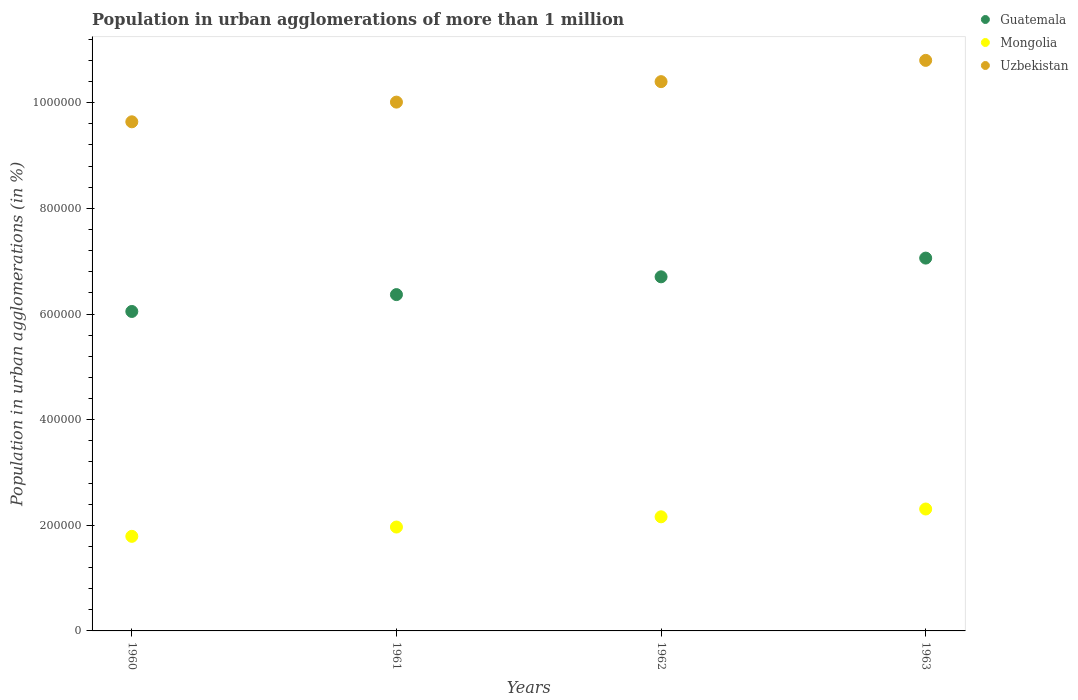How many different coloured dotlines are there?
Provide a short and direct response. 3. What is the population in urban agglomerations in Mongolia in 1960?
Offer a very short reply. 1.79e+05. Across all years, what is the maximum population in urban agglomerations in Mongolia?
Provide a succinct answer. 2.31e+05. Across all years, what is the minimum population in urban agglomerations in Mongolia?
Your response must be concise. 1.79e+05. What is the total population in urban agglomerations in Uzbekistan in the graph?
Give a very brief answer. 4.09e+06. What is the difference between the population in urban agglomerations in Mongolia in 1962 and that in 1963?
Ensure brevity in your answer.  -1.48e+04. What is the difference between the population in urban agglomerations in Mongolia in 1960 and the population in urban agglomerations in Uzbekistan in 1963?
Keep it short and to the point. -9.01e+05. What is the average population in urban agglomerations in Mongolia per year?
Ensure brevity in your answer.  2.06e+05. In the year 1962, what is the difference between the population in urban agglomerations in Guatemala and population in urban agglomerations in Uzbekistan?
Offer a very short reply. -3.70e+05. What is the ratio of the population in urban agglomerations in Guatemala in 1961 to that in 1963?
Keep it short and to the point. 0.9. Is the population in urban agglomerations in Guatemala in 1960 less than that in 1963?
Keep it short and to the point. Yes. What is the difference between the highest and the second highest population in urban agglomerations in Mongolia?
Make the answer very short. 1.48e+04. What is the difference between the highest and the lowest population in urban agglomerations in Mongolia?
Offer a terse response. 5.18e+04. Is the population in urban agglomerations in Guatemala strictly greater than the population in urban agglomerations in Uzbekistan over the years?
Offer a very short reply. No. How many dotlines are there?
Provide a succinct answer. 3. Are the values on the major ticks of Y-axis written in scientific E-notation?
Make the answer very short. No. Where does the legend appear in the graph?
Provide a succinct answer. Top right. How many legend labels are there?
Offer a terse response. 3. How are the legend labels stacked?
Offer a terse response. Vertical. What is the title of the graph?
Make the answer very short. Population in urban agglomerations of more than 1 million. What is the label or title of the X-axis?
Keep it short and to the point. Years. What is the label or title of the Y-axis?
Provide a succinct answer. Population in urban agglomerations (in %). What is the Population in urban agglomerations (in %) in Guatemala in 1960?
Your answer should be very brief. 6.05e+05. What is the Population in urban agglomerations (in %) of Mongolia in 1960?
Provide a succinct answer. 1.79e+05. What is the Population in urban agglomerations (in %) in Uzbekistan in 1960?
Your answer should be very brief. 9.64e+05. What is the Population in urban agglomerations (in %) in Guatemala in 1961?
Your response must be concise. 6.37e+05. What is the Population in urban agglomerations (in %) of Mongolia in 1961?
Provide a short and direct response. 1.97e+05. What is the Population in urban agglomerations (in %) of Uzbekistan in 1961?
Offer a very short reply. 1.00e+06. What is the Population in urban agglomerations (in %) in Guatemala in 1962?
Ensure brevity in your answer.  6.70e+05. What is the Population in urban agglomerations (in %) of Mongolia in 1962?
Keep it short and to the point. 2.16e+05. What is the Population in urban agglomerations (in %) in Uzbekistan in 1962?
Keep it short and to the point. 1.04e+06. What is the Population in urban agglomerations (in %) in Guatemala in 1963?
Make the answer very short. 7.06e+05. What is the Population in urban agglomerations (in %) of Mongolia in 1963?
Your answer should be compact. 2.31e+05. What is the Population in urban agglomerations (in %) in Uzbekistan in 1963?
Offer a terse response. 1.08e+06. Across all years, what is the maximum Population in urban agglomerations (in %) of Guatemala?
Offer a terse response. 7.06e+05. Across all years, what is the maximum Population in urban agglomerations (in %) of Mongolia?
Make the answer very short. 2.31e+05. Across all years, what is the maximum Population in urban agglomerations (in %) in Uzbekistan?
Offer a terse response. 1.08e+06. Across all years, what is the minimum Population in urban agglomerations (in %) in Guatemala?
Offer a very short reply. 6.05e+05. Across all years, what is the minimum Population in urban agglomerations (in %) in Mongolia?
Ensure brevity in your answer.  1.79e+05. Across all years, what is the minimum Population in urban agglomerations (in %) of Uzbekistan?
Your response must be concise. 9.64e+05. What is the total Population in urban agglomerations (in %) of Guatemala in the graph?
Make the answer very short. 2.62e+06. What is the total Population in urban agglomerations (in %) of Mongolia in the graph?
Provide a succinct answer. 8.23e+05. What is the total Population in urban agglomerations (in %) in Uzbekistan in the graph?
Make the answer very short. 4.09e+06. What is the difference between the Population in urban agglomerations (in %) in Guatemala in 1960 and that in 1961?
Keep it short and to the point. -3.19e+04. What is the difference between the Population in urban agglomerations (in %) in Mongolia in 1960 and that in 1961?
Provide a succinct answer. -1.76e+04. What is the difference between the Population in urban agglomerations (in %) of Uzbekistan in 1960 and that in 1961?
Your response must be concise. -3.73e+04. What is the difference between the Population in urban agglomerations (in %) in Guatemala in 1960 and that in 1962?
Provide a succinct answer. -6.56e+04. What is the difference between the Population in urban agglomerations (in %) of Mongolia in 1960 and that in 1962?
Your answer should be compact. -3.70e+04. What is the difference between the Population in urban agglomerations (in %) in Uzbekistan in 1960 and that in 1962?
Ensure brevity in your answer.  -7.60e+04. What is the difference between the Population in urban agglomerations (in %) of Guatemala in 1960 and that in 1963?
Offer a terse response. -1.01e+05. What is the difference between the Population in urban agglomerations (in %) of Mongolia in 1960 and that in 1963?
Your answer should be compact. -5.18e+04. What is the difference between the Population in urban agglomerations (in %) in Uzbekistan in 1960 and that in 1963?
Provide a short and direct response. -1.16e+05. What is the difference between the Population in urban agglomerations (in %) of Guatemala in 1961 and that in 1962?
Offer a terse response. -3.37e+04. What is the difference between the Population in urban agglomerations (in %) of Mongolia in 1961 and that in 1962?
Make the answer very short. -1.94e+04. What is the difference between the Population in urban agglomerations (in %) in Uzbekistan in 1961 and that in 1962?
Your answer should be very brief. -3.88e+04. What is the difference between the Population in urban agglomerations (in %) of Guatemala in 1961 and that in 1963?
Keep it short and to the point. -6.91e+04. What is the difference between the Population in urban agglomerations (in %) in Mongolia in 1961 and that in 1963?
Make the answer very short. -3.41e+04. What is the difference between the Population in urban agglomerations (in %) of Uzbekistan in 1961 and that in 1963?
Offer a terse response. -7.90e+04. What is the difference between the Population in urban agglomerations (in %) of Guatemala in 1962 and that in 1963?
Give a very brief answer. -3.54e+04. What is the difference between the Population in urban agglomerations (in %) in Mongolia in 1962 and that in 1963?
Your answer should be compact. -1.48e+04. What is the difference between the Population in urban agglomerations (in %) of Uzbekistan in 1962 and that in 1963?
Offer a very short reply. -4.03e+04. What is the difference between the Population in urban agglomerations (in %) of Guatemala in 1960 and the Population in urban agglomerations (in %) of Mongolia in 1961?
Your response must be concise. 4.08e+05. What is the difference between the Population in urban agglomerations (in %) in Guatemala in 1960 and the Population in urban agglomerations (in %) in Uzbekistan in 1961?
Provide a short and direct response. -3.96e+05. What is the difference between the Population in urban agglomerations (in %) of Mongolia in 1960 and the Population in urban agglomerations (in %) of Uzbekistan in 1961?
Provide a succinct answer. -8.22e+05. What is the difference between the Population in urban agglomerations (in %) in Guatemala in 1960 and the Population in urban agglomerations (in %) in Mongolia in 1962?
Make the answer very short. 3.89e+05. What is the difference between the Population in urban agglomerations (in %) in Guatemala in 1960 and the Population in urban agglomerations (in %) in Uzbekistan in 1962?
Provide a succinct answer. -4.35e+05. What is the difference between the Population in urban agglomerations (in %) in Mongolia in 1960 and the Population in urban agglomerations (in %) in Uzbekistan in 1962?
Ensure brevity in your answer.  -8.61e+05. What is the difference between the Population in urban agglomerations (in %) in Guatemala in 1960 and the Population in urban agglomerations (in %) in Mongolia in 1963?
Ensure brevity in your answer.  3.74e+05. What is the difference between the Population in urban agglomerations (in %) of Guatemala in 1960 and the Population in urban agglomerations (in %) of Uzbekistan in 1963?
Give a very brief answer. -4.75e+05. What is the difference between the Population in urban agglomerations (in %) of Mongolia in 1960 and the Population in urban agglomerations (in %) of Uzbekistan in 1963?
Your answer should be very brief. -9.01e+05. What is the difference between the Population in urban agglomerations (in %) of Guatemala in 1961 and the Population in urban agglomerations (in %) of Mongolia in 1962?
Your answer should be very brief. 4.21e+05. What is the difference between the Population in urban agglomerations (in %) in Guatemala in 1961 and the Population in urban agglomerations (in %) in Uzbekistan in 1962?
Offer a very short reply. -4.03e+05. What is the difference between the Population in urban agglomerations (in %) in Mongolia in 1961 and the Population in urban agglomerations (in %) in Uzbekistan in 1962?
Ensure brevity in your answer.  -8.43e+05. What is the difference between the Population in urban agglomerations (in %) of Guatemala in 1961 and the Population in urban agglomerations (in %) of Mongolia in 1963?
Ensure brevity in your answer.  4.06e+05. What is the difference between the Population in urban agglomerations (in %) in Guatemala in 1961 and the Population in urban agglomerations (in %) in Uzbekistan in 1963?
Offer a terse response. -4.43e+05. What is the difference between the Population in urban agglomerations (in %) of Mongolia in 1961 and the Population in urban agglomerations (in %) of Uzbekistan in 1963?
Offer a very short reply. -8.84e+05. What is the difference between the Population in urban agglomerations (in %) of Guatemala in 1962 and the Population in urban agglomerations (in %) of Mongolia in 1963?
Make the answer very short. 4.40e+05. What is the difference between the Population in urban agglomerations (in %) in Guatemala in 1962 and the Population in urban agglomerations (in %) in Uzbekistan in 1963?
Your answer should be very brief. -4.10e+05. What is the difference between the Population in urban agglomerations (in %) in Mongolia in 1962 and the Population in urban agglomerations (in %) in Uzbekistan in 1963?
Ensure brevity in your answer.  -8.64e+05. What is the average Population in urban agglomerations (in %) of Guatemala per year?
Keep it short and to the point. 6.54e+05. What is the average Population in urban agglomerations (in %) of Mongolia per year?
Offer a terse response. 2.06e+05. What is the average Population in urban agglomerations (in %) of Uzbekistan per year?
Provide a short and direct response. 1.02e+06. In the year 1960, what is the difference between the Population in urban agglomerations (in %) of Guatemala and Population in urban agglomerations (in %) of Mongolia?
Offer a terse response. 4.26e+05. In the year 1960, what is the difference between the Population in urban agglomerations (in %) in Guatemala and Population in urban agglomerations (in %) in Uzbekistan?
Keep it short and to the point. -3.59e+05. In the year 1960, what is the difference between the Population in urban agglomerations (in %) in Mongolia and Population in urban agglomerations (in %) in Uzbekistan?
Provide a succinct answer. -7.85e+05. In the year 1961, what is the difference between the Population in urban agglomerations (in %) in Guatemala and Population in urban agglomerations (in %) in Mongolia?
Keep it short and to the point. 4.40e+05. In the year 1961, what is the difference between the Population in urban agglomerations (in %) in Guatemala and Population in urban agglomerations (in %) in Uzbekistan?
Keep it short and to the point. -3.64e+05. In the year 1961, what is the difference between the Population in urban agglomerations (in %) of Mongolia and Population in urban agglomerations (in %) of Uzbekistan?
Give a very brief answer. -8.04e+05. In the year 1962, what is the difference between the Population in urban agglomerations (in %) in Guatemala and Population in urban agglomerations (in %) in Mongolia?
Provide a short and direct response. 4.54e+05. In the year 1962, what is the difference between the Population in urban agglomerations (in %) of Guatemala and Population in urban agglomerations (in %) of Uzbekistan?
Make the answer very short. -3.70e+05. In the year 1962, what is the difference between the Population in urban agglomerations (in %) in Mongolia and Population in urban agglomerations (in %) in Uzbekistan?
Your response must be concise. -8.24e+05. In the year 1963, what is the difference between the Population in urban agglomerations (in %) in Guatemala and Population in urban agglomerations (in %) in Mongolia?
Give a very brief answer. 4.75e+05. In the year 1963, what is the difference between the Population in urban agglomerations (in %) in Guatemala and Population in urban agglomerations (in %) in Uzbekistan?
Keep it short and to the point. -3.74e+05. In the year 1963, what is the difference between the Population in urban agglomerations (in %) in Mongolia and Population in urban agglomerations (in %) in Uzbekistan?
Offer a terse response. -8.49e+05. What is the ratio of the Population in urban agglomerations (in %) of Guatemala in 1960 to that in 1961?
Ensure brevity in your answer.  0.95. What is the ratio of the Population in urban agglomerations (in %) in Mongolia in 1960 to that in 1961?
Provide a short and direct response. 0.91. What is the ratio of the Population in urban agglomerations (in %) in Uzbekistan in 1960 to that in 1961?
Ensure brevity in your answer.  0.96. What is the ratio of the Population in urban agglomerations (in %) in Guatemala in 1960 to that in 1962?
Make the answer very short. 0.9. What is the ratio of the Population in urban agglomerations (in %) of Mongolia in 1960 to that in 1962?
Provide a short and direct response. 0.83. What is the ratio of the Population in urban agglomerations (in %) of Uzbekistan in 1960 to that in 1962?
Your answer should be compact. 0.93. What is the ratio of the Population in urban agglomerations (in %) in Guatemala in 1960 to that in 1963?
Provide a succinct answer. 0.86. What is the ratio of the Population in urban agglomerations (in %) in Mongolia in 1960 to that in 1963?
Your answer should be very brief. 0.78. What is the ratio of the Population in urban agglomerations (in %) of Uzbekistan in 1960 to that in 1963?
Offer a very short reply. 0.89. What is the ratio of the Population in urban agglomerations (in %) of Guatemala in 1961 to that in 1962?
Your response must be concise. 0.95. What is the ratio of the Population in urban agglomerations (in %) in Mongolia in 1961 to that in 1962?
Provide a short and direct response. 0.91. What is the ratio of the Population in urban agglomerations (in %) in Uzbekistan in 1961 to that in 1962?
Provide a short and direct response. 0.96. What is the ratio of the Population in urban agglomerations (in %) of Guatemala in 1961 to that in 1963?
Offer a terse response. 0.9. What is the ratio of the Population in urban agglomerations (in %) of Mongolia in 1961 to that in 1963?
Offer a terse response. 0.85. What is the ratio of the Population in urban agglomerations (in %) of Uzbekistan in 1961 to that in 1963?
Ensure brevity in your answer.  0.93. What is the ratio of the Population in urban agglomerations (in %) in Guatemala in 1962 to that in 1963?
Provide a succinct answer. 0.95. What is the ratio of the Population in urban agglomerations (in %) in Mongolia in 1962 to that in 1963?
Offer a terse response. 0.94. What is the ratio of the Population in urban agglomerations (in %) in Uzbekistan in 1962 to that in 1963?
Your answer should be compact. 0.96. What is the difference between the highest and the second highest Population in urban agglomerations (in %) of Guatemala?
Give a very brief answer. 3.54e+04. What is the difference between the highest and the second highest Population in urban agglomerations (in %) in Mongolia?
Give a very brief answer. 1.48e+04. What is the difference between the highest and the second highest Population in urban agglomerations (in %) in Uzbekistan?
Give a very brief answer. 4.03e+04. What is the difference between the highest and the lowest Population in urban agglomerations (in %) of Guatemala?
Keep it short and to the point. 1.01e+05. What is the difference between the highest and the lowest Population in urban agglomerations (in %) in Mongolia?
Make the answer very short. 5.18e+04. What is the difference between the highest and the lowest Population in urban agglomerations (in %) in Uzbekistan?
Keep it short and to the point. 1.16e+05. 